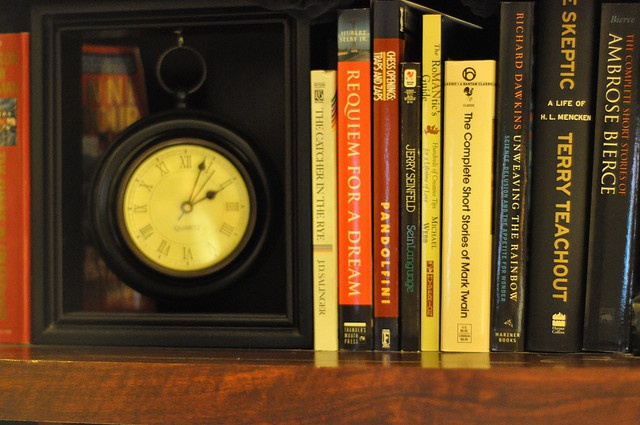Describe the objects in this image and their specific colors. I can see clock in black and gold tones, book in black, orange, and olive tones, book in black, gold, and orange tones, book in black, olive, and khaki tones, and book in black, maroon, and brown tones in this image. 